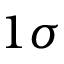<formula> <loc_0><loc_0><loc_500><loc_500>1 \sigma</formula> 